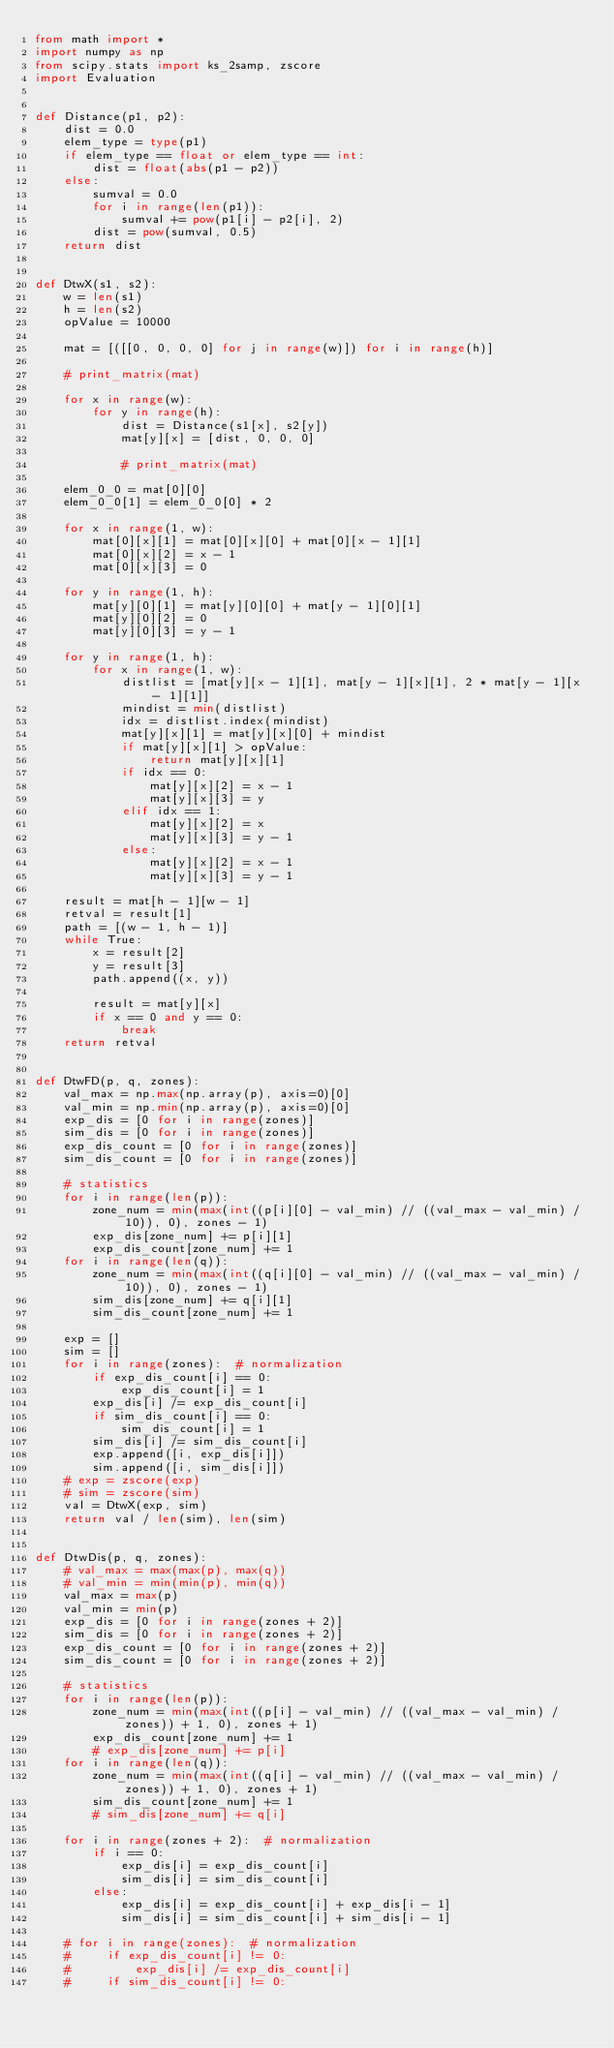Convert code to text. <code><loc_0><loc_0><loc_500><loc_500><_Python_>from math import *
import numpy as np
from scipy.stats import ks_2samp, zscore
import Evaluation


def Distance(p1, p2):
    dist = 0.0
    elem_type = type(p1)
    if elem_type == float or elem_type == int:
        dist = float(abs(p1 - p2))
    else:
        sumval = 0.0
        for i in range(len(p1)):
            sumval += pow(p1[i] - p2[i], 2)
        dist = pow(sumval, 0.5)
    return dist


def DtwX(s1, s2):
    w = len(s1)
    h = len(s2)
    opValue = 10000

    mat = [([[0, 0, 0, 0] for j in range(w)]) for i in range(h)]

    # print_matrix(mat)

    for x in range(w):
        for y in range(h):
            dist = Distance(s1[x], s2[y])
            mat[y][x] = [dist, 0, 0, 0]

            # print_matrix(mat)

    elem_0_0 = mat[0][0]
    elem_0_0[1] = elem_0_0[0] * 2

    for x in range(1, w):
        mat[0][x][1] = mat[0][x][0] + mat[0][x - 1][1]
        mat[0][x][2] = x - 1
        mat[0][x][3] = 0

    for y in range(1, h):
        mat[y][0][1] = mat[y][0][0] + mat[y - 1][0][1]
        mat[y][0][2] = 0
        mat[y][0][3] = y - 1

    for y in range(1, h):
        for x in range(1, w):
            distlist = [mat[y][x - 1][1], mat[y - 1][x][1], 2 * mat[y - 1][x - 1][1]]
            mindist = min(distlist)
            idx = distlist.index(mindist)
            mat[y][x][1] = mat[y][x][0] + mindist
            if mat[y][x][1] > opValue:
                return mat[y][x][1]
            if idx == 0:
                mat[y][x][2] = x - 1
                mat[y][x][3] = y
            elif idx == 1:
                mat[y][x][2] = x
                mat[y][x][3] = y - 1
            else:
                mat[y][x][2] = x - 1
                mat[y][x][3] = y - 1

    result = mat[h - 1][w - 1]
    retval = result[1]
    path = [(w - 1, h - 1)]
    while True:
        x = result[2]
        y = result[3]
        path.append((x, y))

        result = mat[y][x]
        if x == 0 and y == 0:
            break
    return retval


def DtwFD(p, q, zones):
    val_max = np.max(np.array(p), axis=0)[0]
    val_min = np.min(np.array(p), axis=0)[0]
    exp_dis = [0 for i in range(zones)]
    sim_dis = [0 for i in range(zones)]
    exp_dis_count = [0 for i in range(zones)]
    sim_dis_count = [0 for i in range(zones)]

    # statistics
    for i in range(len(p)):
        zone_num = min(max(int((p[i][0] - val_min) // ((val_max - val_min) / 10)), 0), zones - 1)
        exp_dis[zone_num] += p[i][1]
        exp_dis_count[zone_num] += 1
    for i in range(len(q)):
        zone_num = min(max(int((q[i][0] - val_min) // ((val_max - val_min) / 10)), 0), zones - 1)
        sim_dis[zone_num] += q[i][1]
        sim_dis_count[zone_num] += 1

    exp = []
    sim = []
    for i in range(zones):  # normalization
        if exp_dis_count[i] == 0:
            exp_dis_count[i] = 1
        exp_dis[i] /= exp_dis_count[i]
        if sim_dis_count[i] == 0:
            sim_dis_count[i] = 1
        sim_dis[i] /= sim_dis_count[i]
        exp.append([i, exp_dis[i]])
        sim.append([i, sim_dis[i]])
    # exp = zscore(exp)
    # sim = zscore(sim)
    val = DtwX(exp, sim)
    return val / len(sim), len(sim)


def DtwDis(p, q, zones):
    # val_max = max(max(p), max(q))
    # val_min = min(min(p), min(q))
    val_max = max(p)
    val_min = min(p)
    exp_dis = [0 for i in range(zones + 2)]
    sim_dis = [0 for i in range(zones + 2)]
    exp_dis_count = [0 for i in range(zones + 2)]
    sim_dis_count = [0 for i in range(zones + 2)]

    # statistics
    for i in range(len(p)):
        zone_num = min(max(int((p[i] - val_min) // ((val_max - val_min) / zones)) + 1, 0), zones + 1)
        exp_dis_count[zone_num] += 1
        # exp_dis[zone_num] += p[i]
    for i in range(len(q)):
        zone_num = min(max(int((q[i] - val_min) // ((val_max - val_min) / zones)) + 1, 0), zones + 1)
        sim_dis_count[zone_num] += 1
        # sim_dis[zone_num] += q[i]

    for i in range(zones + 2):  # normalization
        if i == 0:
            exp_dis[i] = exp_dis_count[i]
            sim_dis[i] = sim_dis_count[i]
        else:
            exp_dis[i] = exp_dis_count[i] + exp_dis[i - 1]
            sim_dis[i] = sim_dis_count[i] + sim_dis[i - 1]

    # for i in range(zones):  # normalization
    #     if exp_dis_count[i] != 0:
    #         exp_dis[i] /= exp_dis_count[i]
    #     if sim_dis_count[i] != 0:</code> 